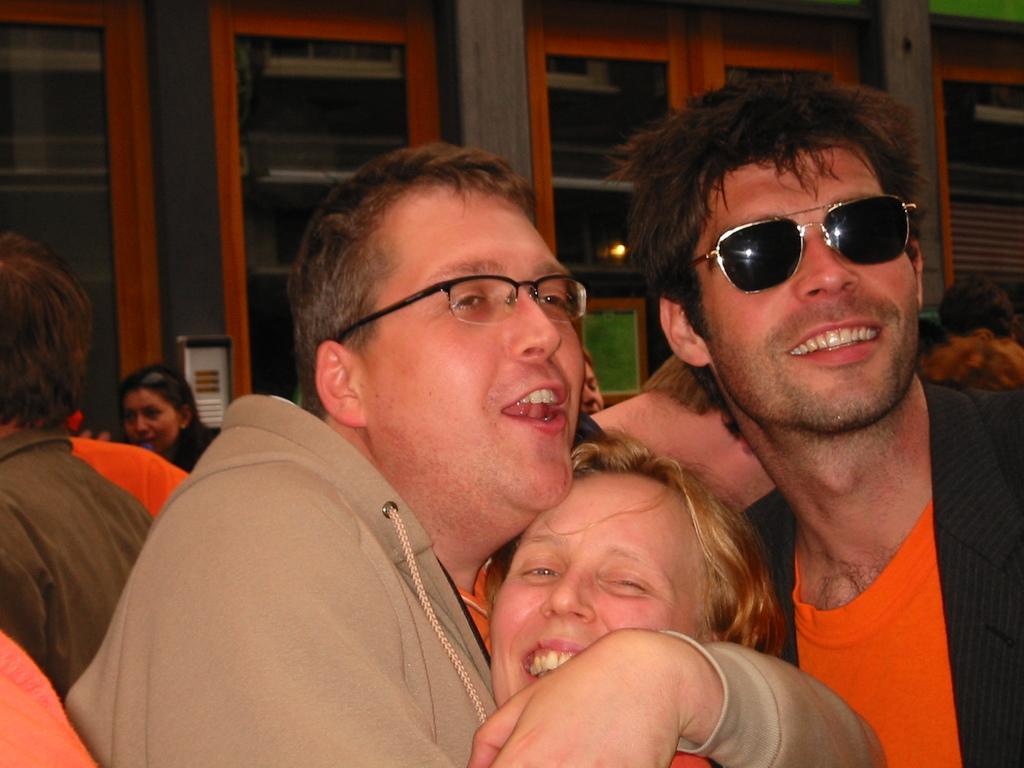How would you summarize this image in a sentence or two? In this image we can see a few people, among them two are wearing the spectacles, in the background, we can see the pillars and windows. 